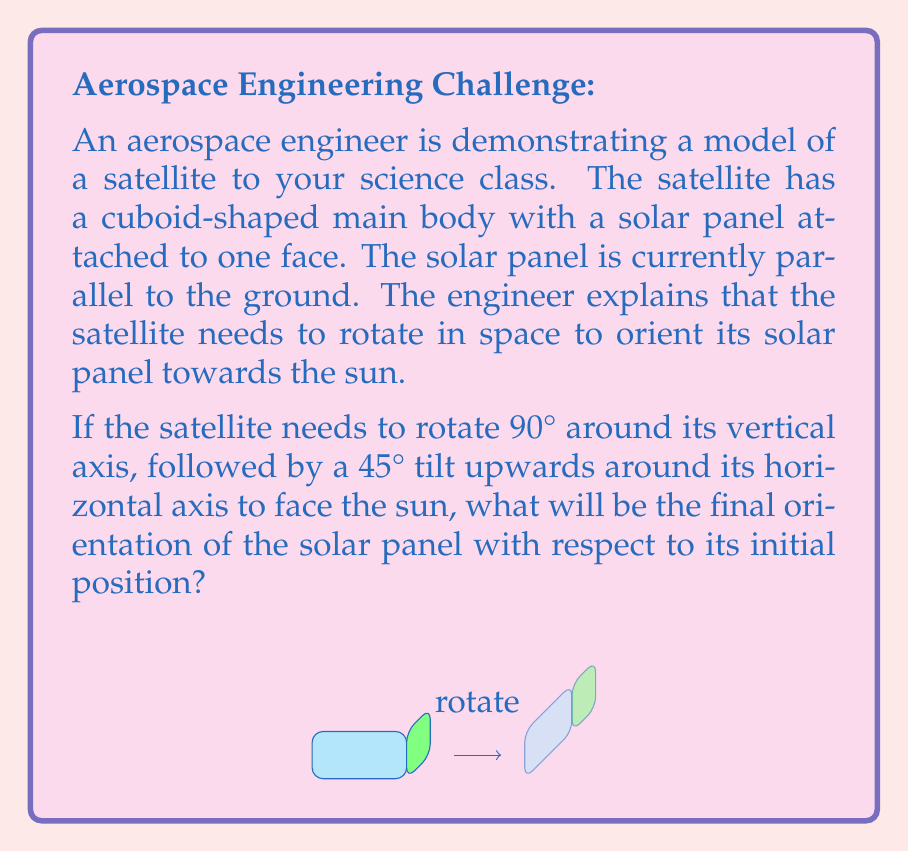Could you help me with this problem? To solve this problem, let's break it down into steps:

1) First, we need to understand the sequence of rotations:
   a) 90° rotation around the vertical axis (z-axis)
   b) 45° tilt upwards around the horizontal axis (x-axis)

2) The 90° rotation around the z-axis doesn't change the orientation of the solar panel relative to the ground. It only changes its position in the xy-plane.

3) The 45° tilt upwards around the x-axis is what changes the orientation of the solar panel. This rotation can be represented by the rotation matrix:

   $$R_x(45°) = \begin{pmatrix}
   1 & 0 & 0 \\
   0 & \cos 45° & -\sin 45° \\
   0 & \sin 45° & \cos 45°
   \end{pmatrix}$$

4) The normal vector of the solar panel before rotation is $\vec{n} = (0, 0, 1)$.

5) After rotation, the new normal vector $\vec{n'}$ is:

   $$\vec{n'} = R_x(45°) \cdot \vec{n} = \begin{pmatrix}
   1 & 0 & 0 \\
   0 & \frac{\sqrt{2}}{2} & -\frac{\sqrt{2}}{2} \\
   0 & \frac{\sqrt{2}}{2} & \frac{\sqrt{2}}{2}
   \end{pmatrix} \cdot \begin{pmatrix} 0 \\ 0 \\ 1 \end{pmatrix} = \begin{pmatrix} 0 \\ -\frac{\sqrt{2}}{2} \\ \frac{\sqrt{2}}{2} \end{pmatrix}$$

6) The angle between the initial and final position of the solar panel can be calculated using the dot product:

   $$\cos \theta = \frac{\vec{n} \cdot \vec{n'}}{|\vec{n}||\vec{n'}|} = \frac{0 \cdot 0 + 0 \cdot (-\frac{\sqrt{2}}{2}) + 1 \cdot \frac{\sqrt{2}}{2}}{1 \cdot 1} = \frac{\sqrt{2}}{2}$$

7) Therefore, $\theta = \arccos(\frac{\sqrt{2}}{2}) = 45°$

Thus, the final orientation of the solar panel is at a 45° angle with respect to its initial position.
Answer: 45° 